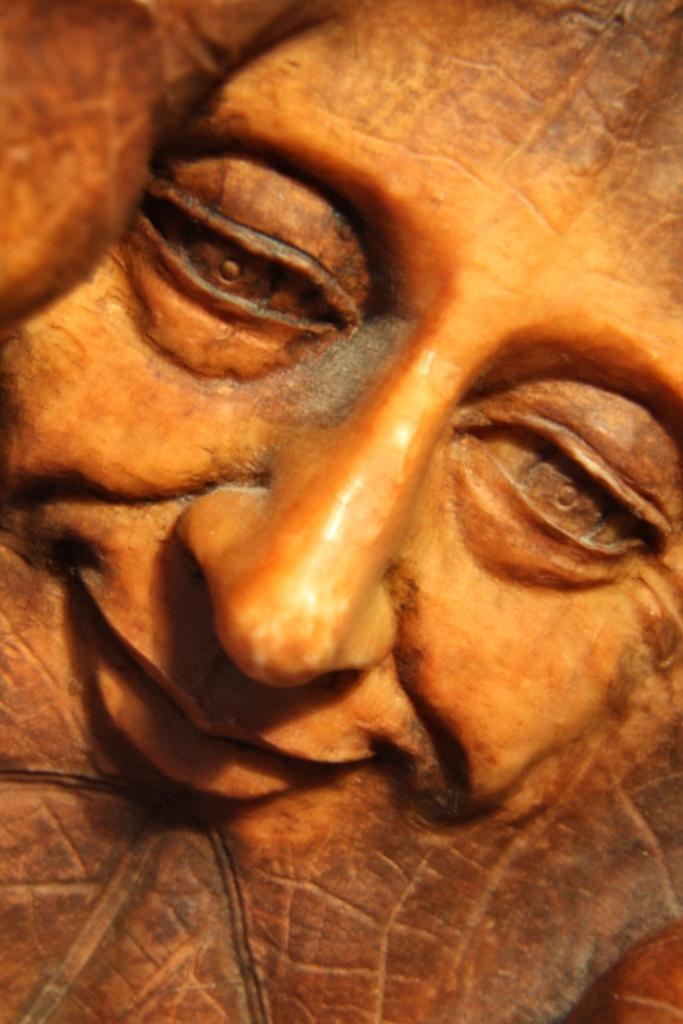How would you summarize this image in a sentence or two? In this image I see a sculpture of a face which is of brown and orange in color. 